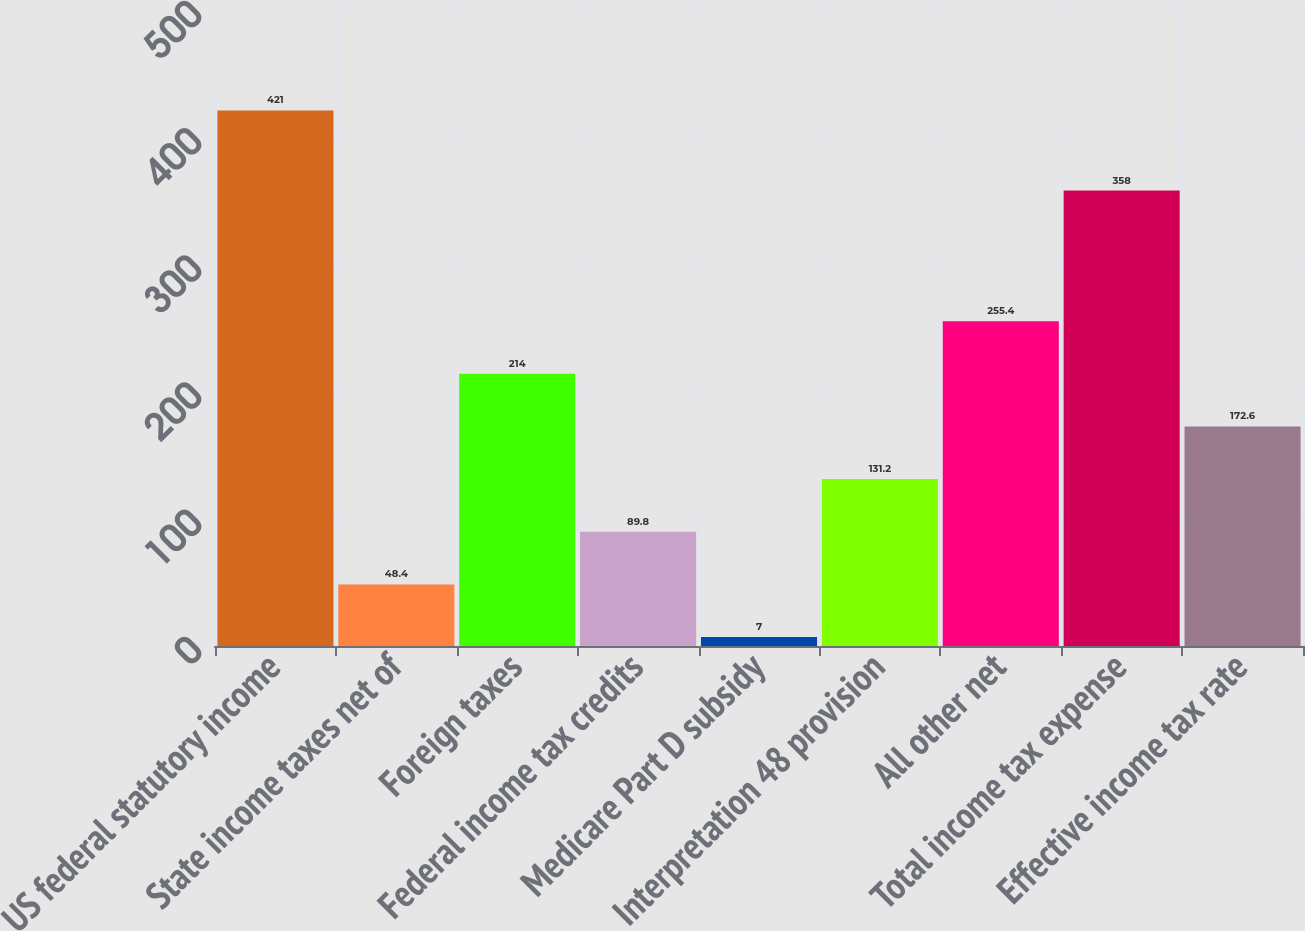Convert chart. <chart><loc_0><loc_0><loc_500><loc_500><bar_chart><fcel>US federal statutory income<fcel>State income taxes net of<fcel>Foreign taxes<fcel>Federal income tax credits<fcel>Medicare Part D subsidy<fcel>Interpretation 48 provision<fcel>All other net<fcel>Total income tax expense<fcel>Effective income tax rate<nl><fcel>421<fcel>48.4<fcel>214<fcel>89.8<fcel>7<fcel>131.2<fcel>255.4<fcel>358<fcel>172.6<nl></chart> 